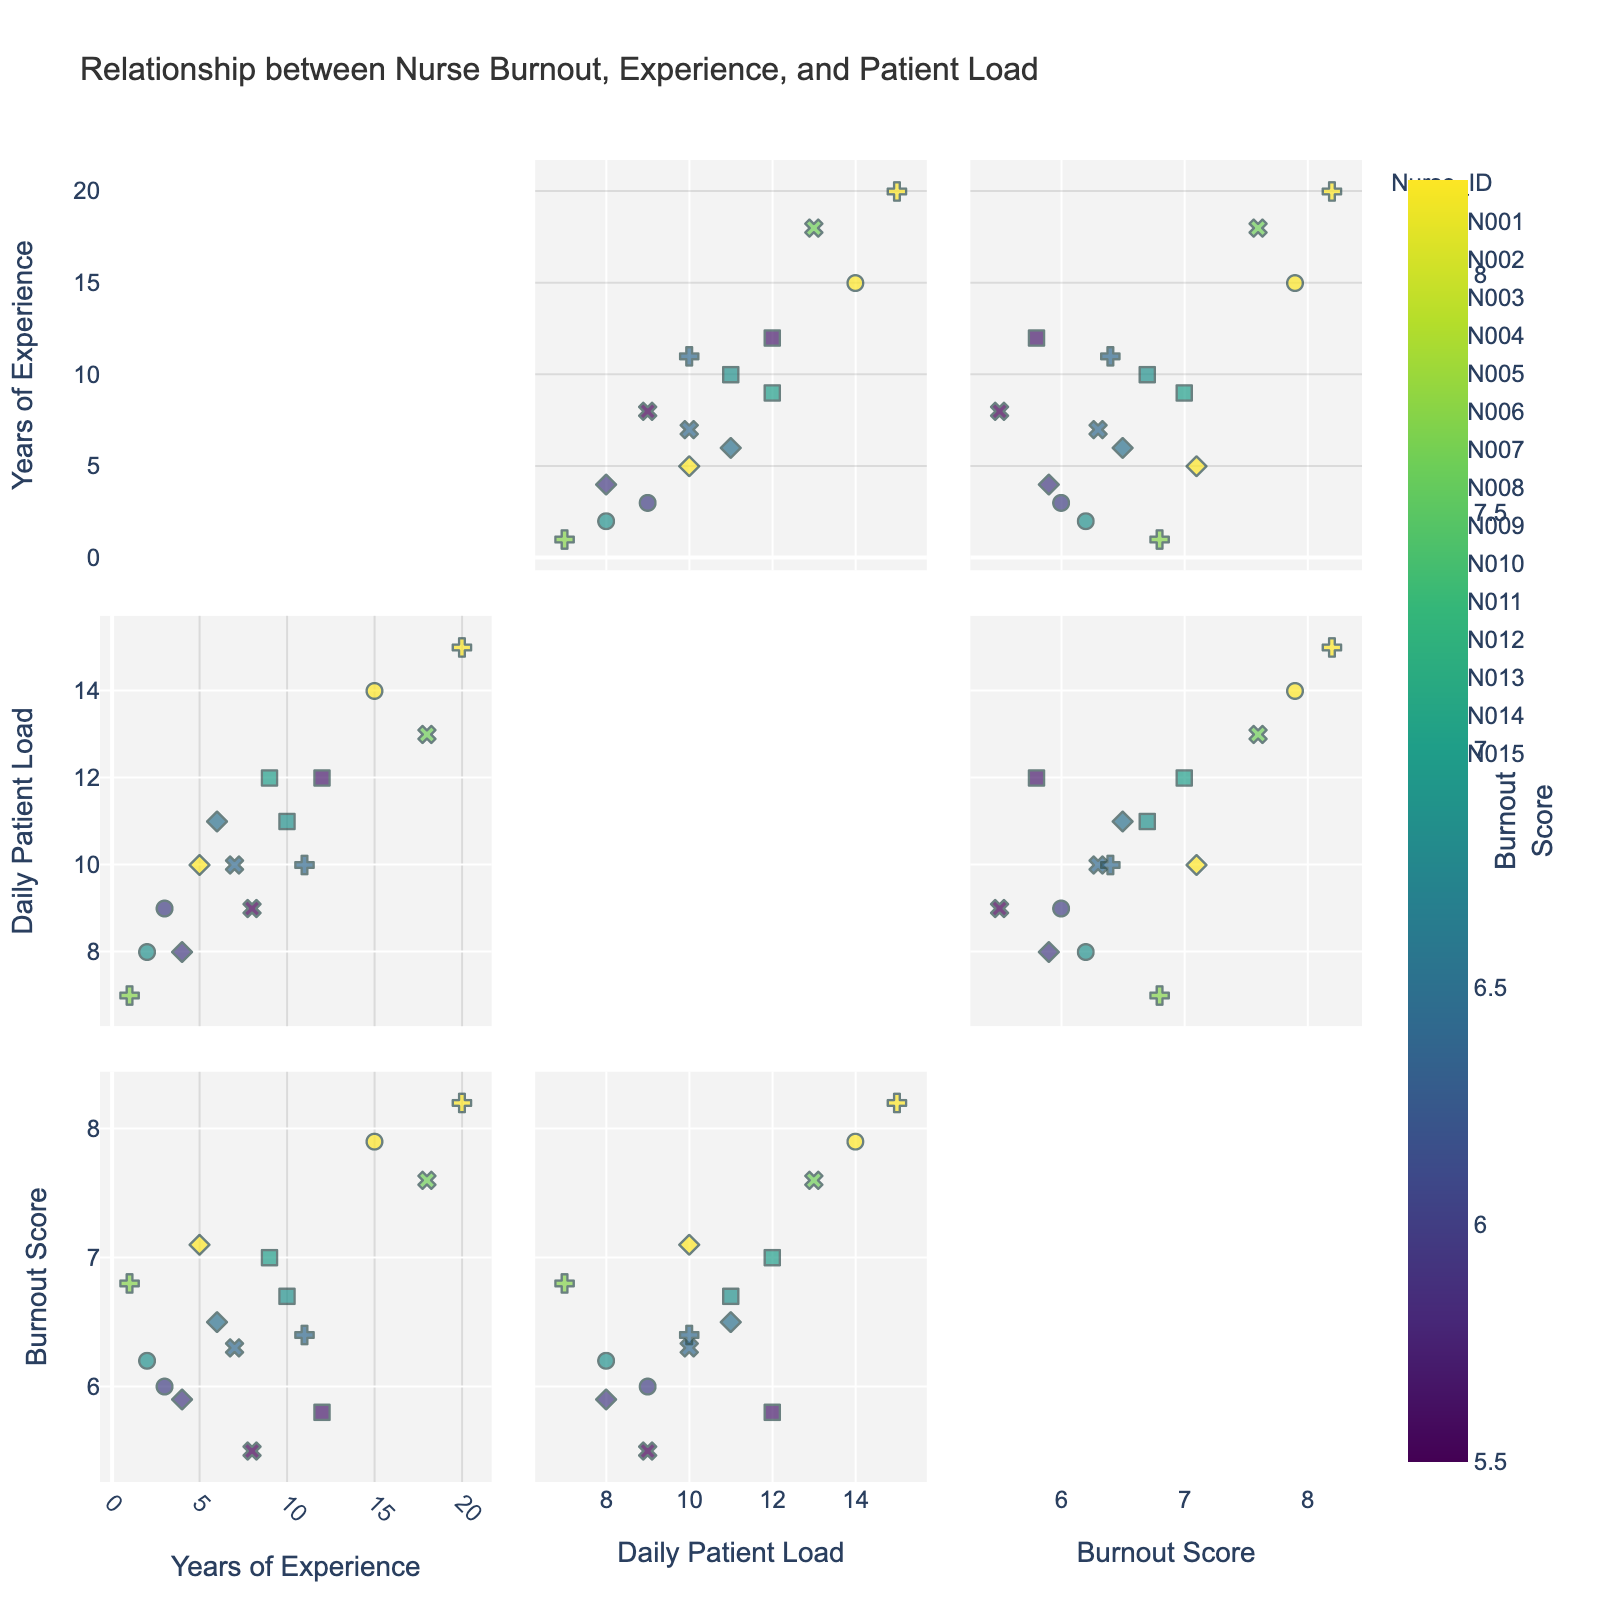What's the title of the figure? The title of the figure is written at the top and typically summarizes what the plot is about. It reads "Relationship between Nurse Burnout, Experience, and Patient Load."
Answer: Relationship between Nurse Burnout, Experience, and Patient Load How many dimensions are analyzed in this scatterplot matrix? In a scatterplot matrix, each dimension represents a variable analyzed in pairs. The axes of the subplots indicate that three dimensions are considered: 'Years of Experience', 'Daily Patient Load', and 'Burnout Score'.
Answer: Three Which axis represents the 'Daily Patient Load' in the scatterplot matrix? Each axis in the scatterplot matrix represents one variable. By looking at the scatterplot matrix, 'Daily Patient Load' is labeled on both the horizontal and vertical axes in different subplots.
Answer: Both horizontal and vertical Which nurse has the highest 'Burnout Score'? Each point represents a nurse, with the color intensity indicating the 'Burnout Score'. The nurse with the highest burnout score will appear as the darkest point. By examining the color scale, Nurse N010 has a burnout score of 8.2, the highest score in the dataset.
Answer: Nurse N010 Is there a general trend between 'Years of Experience' and 'Burnout Score'? Looking at the scatter plots where 'Years of Experience' is plotted against 'Burnout Score', we observe that burnout scores vary across years of experience without a clear linear trend. There isn't a strong visual indication of a positive or negative relationship.
Answer: No clear trend What's the average 'Daily Patient Load' for nurses with more than 10 Years of Experience? Identify nurses with more than 10 years of experience: Nurses N003, N006, N010, N013, N014, and N015. The corresponding daily patient loads are 12, 14, 15, 12, 13, and 10. Sum these values and divide by the number of data points (6) to get the average: (12+14+15+12+13+10)/6 = 12.67.
Answer: 12.67 Compare the 'Burnout Scores' for nurses with 5 years and 15 years of experience. Which one is higher on average? The nurse with 5 years of experience (N002) has a 'Burnout Score' of 7.1. The nurse with 15 years of experience (N006) has a 'Burnout Score' of 7.9. The individual values indicate that the nurse with 15 years of experience has a higher burnout score on average.
Answer: 15 years What pattern do you see between 'Years of Experience' and 'Daily Patient Load'? Examining the scatter plots showing 'Years of Experience' vs 'Daily Patient Load', there seems to be a slight trend that as 'Years of Experience' increases, the 'Daily Patient Load' also tends to increase, although there are exceptions.
Answer: Slight positive trend What is the median 'Burnout Score' for all nurses? To find the median, list all 'Burnout Scores' in ascending order: 5.5, 5.8, 5.9, 6.0, 6.2, 6.3, 6.4, 6.5, 6.7, 6.8, 7.0, 7.1, 7.6, 7.9, 8.2. The median is the middle value in the ordered list, which is the 8th value, 6.5.
Answer: 6.5 Do nurses with higher daily patient loads generally have higher burnout scores? Observing the scatter plots where 'Daily Patient Load' is plotted against 'Burnout Score', it's evident that there tends to be a positive correlation where nurses with higher patient loads experience higher burnout scores.
Answer: Yes 